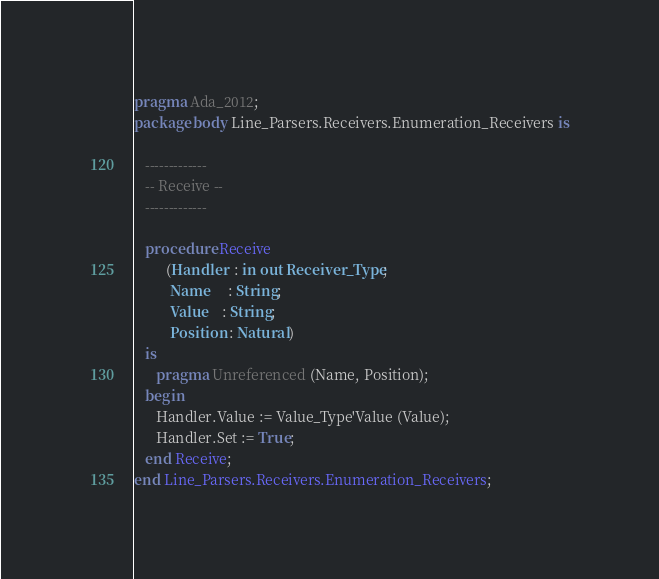Convert code to text. <code><loc_0><loc_0><loc_500><loc_500><_Ada_>pragma Ada_2012;
package body Line_Parsers.Receivers.Enumeration_Receivers is

   -------------
   -- Receive --
   -------------

   procedure Receive
         (Handler  : in out Receiver_Type;
          Name     : String;
          Value    : String;
          Position : Natural)
   is
      pragma Unreferenced (Name, Position);
   begin
      Handler.Value := Value_Type'Value (Value);
      Handler.Set := True;
   end Receive;
end Line_Parsers.Receivers.Enumeration_Receivers;
</code> 